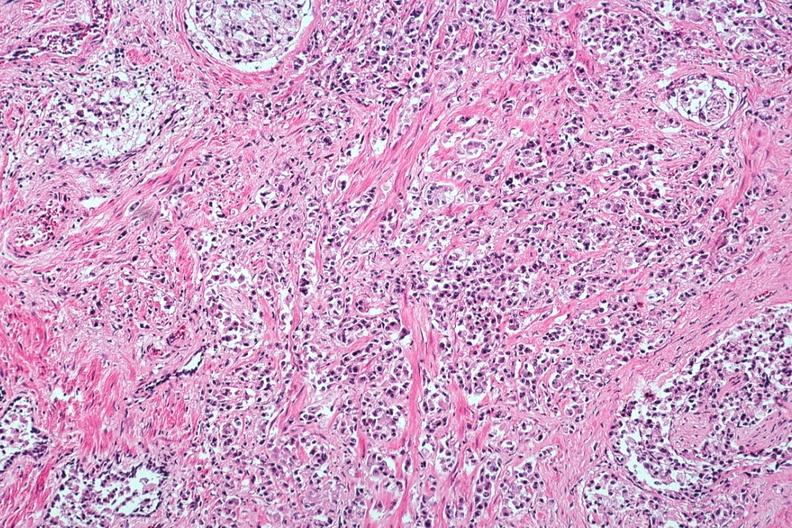s adenocarcinoma present?
Answer the question using a single word or phrase. Yes 